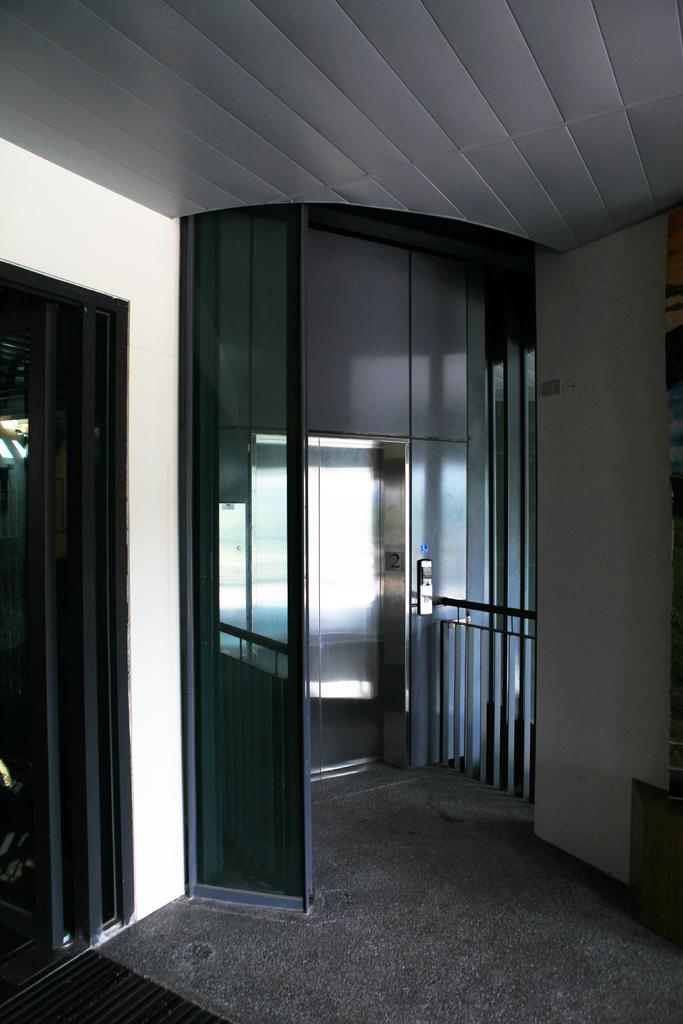What type of transportation is present in the image? There is an elevator in the image. What type of flooring is visible in the image? There is a carpet on the floor in the image. What type of structure is present in the image? There is a wall in the image. What type of game is being played in the image? There is no game being played in the image; it only features an elevator, carpet, and wall. 